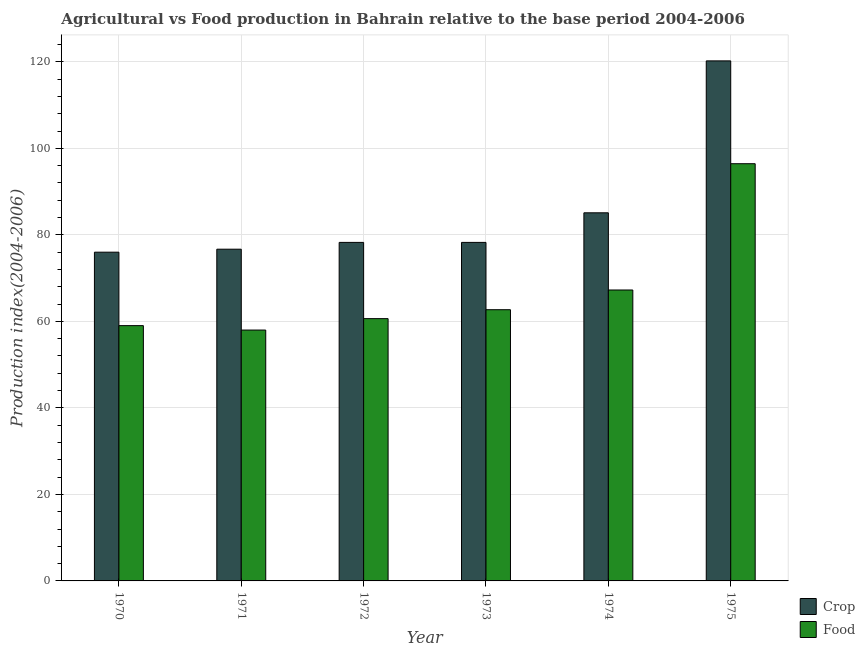Are the number of bars on each tick of the X-axis equal?
Ensure brevity in your answer.  Yes. How many bars are there on the 6th tick from the right?
Provide a short and direct response. 2. What is the food production index in 1973?
Provide a short and direct response. 62.69. Across all years, what is the maximum food production index?
Make the answer very short. 96.44. Across all years, what is the minimum crop production index?
Your response must be concise. 75.99. In which year was the crop production index maximum?
Give a very brief answer. 1975. What is the total crop production index in the graph?
Offer a terse response. 514.47. What is the difference between the crop production index in 1971 and that in 1973?
Your answer should be very brief. -1.57. What is the difference between the crop production index in 1974 and the food production index in 1970?
Your answer should be very brief. 9.1. What is the average crop production index per year?
Provide a short and direct response. 85.75. In the year 1974, what is the difference between the food production index and crop production index?
Provide a short and direct response. 0. What is the ratio of the food production index in 1972 to that in 1973?
Your answer should be very brief. 0.97. Is the food production index in 1974 less than that in 1975?
Make the answer very short. Yes. What is the difference between the highest and the second highest food production index?
Your answer should be compact. 29.19. What is the difference between the highest and the lowest food production index?
Offer a very short reply. 38.45. Is the sum of the crop production index in 1970 and 1974 greater than the maximum food production index across all years?
Make the answer very short. Yes. What does the 1st bar from the left in 1973 represents?
Make the answer very short. Crop. What does the 2nd bar from the right in 1972 represents?
Ensure brevity in your answer.  Crop. How many bars are there?
Your answer should be very brief. 12. Are all the bars in the graph horizontal?
Keep it short and to the point. No. Are the values on the major ticks of Y-axis written in scientific E-notation?
Offer a very short reply. No. How many legend labels are there?
Offer a very short reply. 2. How are the legend labels stacked?
Your answer should be compact. Vertical. What is the title of the graph?
Your answer should be very brief. Agricultural vs Food production in Bahrain relative to the base period 2004-2006. Does "Canada" appear as one of the legend labels in the graph?
Ensure brevity in your answer.  No. What is the label or title of the X-axis?
Ensure brevity in your answer.  Year. What is the label or title of the Y-axis?
Your response must be concise. Production index(2004-2006). What is the Production index(2004-2006) of Crop in 1970?
Ensure brevity in your answer.  75.99. What is the Production index(2004-2006) of Food in 1970?
Your response must be concise. 59.01. What is the Production index(2004-2006) in Crop in 1971?
Your response must be concise. 76.68. What is the Production index(2004-2006) in Food in 1971?
Your answer should be compact. 57.99. What is the Production index(2004-2006) of Crop in 1972?
Ensure brevity in your answer.  78.25. What is the Production index(2004-2006) in Food in 1972?
Your answer should be compact. 60.63. What is the Production index(2004-2006) in Crop in 1973?
Your response must be concise. 78.25. What is the Production index(2004-2006) of Food in 1973?
Keep it short and to the point. 62.69. What is the Production index(2004-2006) of Crop in 1974?
Your response must be concise. 85.09. What is the Production index(2004-2006) of Food in 1974?
Provide a short and direct response. 67.25. What is the Production index(2004-2006) in Crop in 1975?
Offer a terse response. 120.21. What is the Production index(2004-2006) of Food in 1975?
Ensure brevity in your answer.  96.44. Across all years, what is the maximum Production index(2004-2006) of Crop?
Offer a very short reply. 120.21. Across all years, what is the maximum Production index(2004-2006) in Food?
Ensure brevity in your answer.  96.44. Across all years, what is the minimum Production index(2004-2006) in Crop?
Ensure brevity in your answer.  75.99. Across all years, what is the minimum Production index(2004-2006) in Food?
Ensure brevity in your answer.  57.99. What is the total Production index(2004-2006) of Crop in the graph?
Keep it short and to the point. 514.47. What is the total Production index(2004-2006) of Food in the graph?
Make the answer very short. 404.01. What is the difference between the Production index(2004-2006) in Crop in 1970 and that in 1971?
Keep it short and to the point. -0.69. What is the difference between the Production index(2004-2006) of Food in 1970 and that in 1971?
Ensure brevity in your answer.  1.02. What is the difference between the Production index(2004-2006) in Crop in 1970 and that in 1972?
Your answer should be very brief. -2.26. What is the difference between the Production index(2004-2006) in Food in 1970 and that in 1972?
Your response must be concise. -1.62. What is the difference between the Production index(2004-2006) in Crop in 1970 and that in 1973?
Keep it short and to the point. -2.26. What is the difference between the Production index(2004-2006) of Food in 1970 and that in 1973?
Ensure brevity in your answer.  -3.68. What is the difference between the Production index(2004-2006) of Crop in 1970 and that in 1974?
Provide a short and direct response. -9.1. What is the difference between the Production index(2004-2006) of Food in 1970 and that in 1974?
Offer a very short reply. -8.24. What is the difference between the Production index(2004-2006) in Crop in 1970 and that in 1975?
Ensure brevity in your answer.  -44.22. What is the difference between the Production index(2004-2006) of Food in 1970 and that in 1975?
Provide a short and direct response. -37.43. What is the difference between the Production index(2004-2006) in Crop in 1971 and that in 1972?
Your answer should be very brief. -1.57. What is the difference between the Production index(2004-2006) in Food in 1971 and that in 1972?
Ensure brevity in your answer.  -2.64. What is the difference between the Production index(2004-2006) of Crop in 1971 and that in 1973?
Provide a short and direct response. -1.57. What is the difference between the Production index(2004-2006) in Food in 1971 and that in 1973?
Provide a succinct answer. -4.7. What is the difference between the Production index(2004-2006) of Crop in 1971 and that in 1974?
Offer a very short reply. -8.41. What is the difference between the Production index(2004-2006) of Food in 1971 and that in 1974?
Your response must be concise. -9.26. What is the difference between the Production index(2004-2006) in Crop in 1971 and that in 1975?
Give a very brief answer. -43.53. What is the difference between the Production index(2004-2006) of Food in 1971 and that in 1975?
Your answer should be very brief. -38.45. What is the difference between the Production index(2004-2006) of Food in 1972 and that in 1973?
Offer a terse response. -2.06. What is the difference between the Production index(2004-2006) of Crop in 1972 and that in 1974?
Keep it short and to the point. -6.84. What is the difference between the Production index(2004-2006) of Food in 1972 and that in 1974?
Offer a very short reply. -6.62. What is the difference between the Production index(2004-2006) of Crop in 1972 and that in 1975?
Your answer should be compact. -41.96. What is the difference between the Production index(2004-2006) of Food in 1972 and that in 1975?
Give a very brief answer. -35.81. What is the difference between the Production index(2004-2006) in Crop in 1973 and that in 1974?
Your answer should be very brief. -6.84. What is the difference between the Production index(2004-2006) in Food in 1973 and that in 1974?
Offer a very short reply. -4.56. What is the difference between the Production index(2004-2006) of Crop in 1973 and that in 1975?
Keep it short and to the point. -41.96. What is the difference between the Production index(2004-2006) in Food in 1973 and that in 1975?
Provide a short and direct response. -33.75. What is the difference between the Production index(2004-2006) in Crop in 1974 and that in 1975?
Ensure brevity in your answer.  -35.12. What is the difference between the Production index(2004-2006) of Food in 1974 and that in 1975?
Offer a very short reply. -29.19. What is the difference between the Production index(2004-2006) of Crop in 1970 and the Production index(2004-2006) of Food in 1971?
Give a very brief answer. 18. What is the difference between the Production index(2004-2006) of Crop in 1970 and the Production index(2004-2006) of Food in 1972?
Your answer should be very brief. 15.36. What is the difference between the Production index(2004-2006) in Crop in 1970 and the Production index(2004-2006) in Food in 1974?
Make the answer very short. 8.74. What is the difference between the Production index(2004-2006) of Crop in 1970 and the Production index(2004-2006) of Food in 1975?
Offer a terse response. -20.45. What is the difference between the Production index(2004-2006) in Crop in 1971 and the Production index(2004-2006) in Food in 1972?
Offer a very short reply. 16.05. What is the difference between the Production index(2004-2006) in Crop in 1971 and the Production index(2004-2006) in Food in 1973?
Your answer should be very brief. 13.99. What is the difference between the Production index(2004-2006) of Crop in 1971 and the Production index(2004-2006) of Food in 1974?
Provide a short and direct response. 9.43. What is the difference between the Production index(2004-2006) of Crop in 1971 and the Production index(2004-2006) of Food in 1975?
Give a very brief answer. -19.76. What is the difference between the Production index(2004-2006) in Crop in 1972 and the Production index(2004-2006) in Food in 1973?
Provide a succinct answer. 15.56. What is the difference between the Production index(2004-2006) in Crop in 1972 and the Production index(2004-2006) in Food in 1975?
Make the answer very short. -18.19. What is the difference between the Production index(2004-2006) in Crop in 1973 and the Production index(2004-2006) in Food in 1974?
Offer a very short reply. 11. What is the difference between the Production index(2004-2006) in Crop in 1973 and the Production index(2004-2006) in Food in 1975?
Your response must be concise. -18.19. What is the difference between the Production index(2004-2006) in Crop in 1974 and the Production index(2004-2006) in Food in 1975?
Keep it short and to the point. -11.35. What is the average Production index(2004-2006) of Crop per year?
Offer a terse response. 85.75. What is the average Production index(2004-2006) of Food per year?
Provide a short and direct response. 67.33. In the year 1970, what is the difference between the Production index(2004-2006) of Crop and Production index(2004-2006) of Food?
Offer a terse response. 16.98. In the year 1971, what is the difference between the Production index(2004-2006) in Crop and Production index(2004-2006) in Food?
Ensure brevity in your answer.  18.69. In the year 1972, what is the difference between the Production index(2004-2006) of Crop and Production index(2004-2006) of Food?
Ensure brevity in your answer.  17.62. In the year 1973, what is the difference between the Production index(2004-2006) in Crop and Production index(2004-2006) in Food?
Give a very brief answer. 15.56. In the year 1974, what is the difference between the Production index(2004-2006) in Crop and Production index(2004-2006) in Food?
Offer a very short reply. 17.84. In the year 1975, what is the difference between the Production index(2004-2006) of Crop and Production index(2004-2006) of Food?
Provide a succinct answer. 23.77. What is the ratio of the Production index(2004-2006) in Food in 1970 to that in 1971?
Give a very brief answer. 1.02. What is the ratio of the Production index(2004-2006) in Crop in 1970 to that in 1972?
Ensure brevity in your answer.  0.97. What is the ratio of the Production index(2004-2006) in Food in 1970 to that in 1972?
Provide a succinct answer. 0.97. What is the ratio of the Production index(2004-2006) of Crop in 1970 to that in 1973?
Make the answer very short. 0.97. What is the ratio of the Production index(2004-2006) in Food in 1970 to that in 1973?
Offer a terse response. 0.94. What is the ratio of the Production index(2004-2006) of Crop in 1970 to that in 1974?
Provide a succinct answer. 0.89. What is the ratio of the Production index(2004-2006) of Food in 1970 to that in 1974?
Your answer should be compact. 0.88. What is the ratio of the Production index(2004-2006) in Crop in 1970 to that in 1975?
Your response must be concise. 0.63. What is the ratio of the Production index(2004-2006) of Food in 1970 to that in 1975?
Your answer should be compact. 0.61. What is the ratio of the Production index(2004-2006) in Crop in 1971 to that in 1972?
Your answer should be compact. 0.98. What is the ratio of the Production index(2004-2006) in Food in 1971 to that in 1972?
Your answer should be very brief. 0.96. What is the ratio of the Production index(2004-2006) in Crop in 1971 to that in 1973?
Your answer should be very brief. 0.98. What is the ratio of the Production index(2004-2006) in Food in 1971 to that in 1973?
Provide a short and direct response. 0.93. What is the ratio of the Production index(2004-2006) of Crop in 1971 to that in 1974?
Offer a terse response. 0.9. What is the ratio of the Production index(2004-2006) of Food in 1971 to that in 1974?
Provide a succinct answer. 0.86. What is the ratio of the Production index(2004-2006) in Crop in 1971 to that in 1975?
Offer a very short reply. 0.64. What is the ratio of the Production index(2004-2006) of Food in 1971 to that in 1975?
Your response must be concise. 0.6. What is the ratio of the Production index(2004-2006) in Crop in 1972 to that in 1973?
Ensure brevity in your answer.  1. What is the ratio of the Production index(2004-2006) of Food in 1972 to that in 1973?
Keep it short and to the point. 0.97. What is the ratio of the Production index(2004-2006) of Crop in 1972 to that in 1974?
Give a very brief answer. 0.92. What is the ratio of the Production index(2004-2006) in Food in 1972 to that in 1974?
Your response must be concise. 0.9. What is the ratio of the Production index(2004-2006) of Crop in 1972 to that in 1975?
Your answer should be very brief. 0.65. What is the ratio of the Production index(2004-2006) in Food in 1972 to that in 1975?
Your answer should be compact. 0.63. What is the ratio of the Production index(2004-2006) in Crop in 1973 to that in 1974?
Keep it short and to the point. 0.92. What is the ratio of the Production index(2004-2006) in Food in 1973 to that in 1974?
Make the answer very short. 0.93. What is the ratio of the Production index(2004-2006) in Crop in 1973 to that in 1975?
Give a very brief answer. 0.65. What is the ratio of the Production index(2004-2006) in Food in 1973 to that in 1975?
Your response must be concise. 0.65. What is the ratio of the Production index(2004-2006) in Crop in 1974 to that in 1975?
Provide a succinct answer. 0.71. What is the ratio of the Production index(2004-2006) in Food in 1974 to that in 1975?
Your answer should be very brief. 0.7. What is the difference between the highest and the second highest Production index(2004-2006) of Crop?
Ensure brevity in your answer.  35.12. What is the difference between the highest and the second highest Production index(2004-2006) of Food?
Make the answer very short. 29.19. What is the difference between the highest and the lowest Production index(2004-2006) in Crop?
Give a very brief answer. 44.22. What is the difference between the highest and the lowest Production index(2004-2006) in Food?
Your answer should be compact. 38.45. 